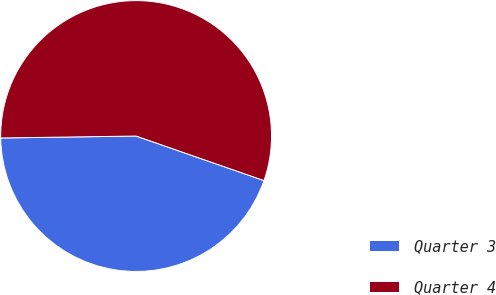Convert chart to OTSL. <chart><loc_0><loc_0><loc_500><loc_500><pie_chart><fcel>Quarter 3<fcel>Quarter 4<nl><fcel>44.44%<fcel>55.56%<nl></chart> 